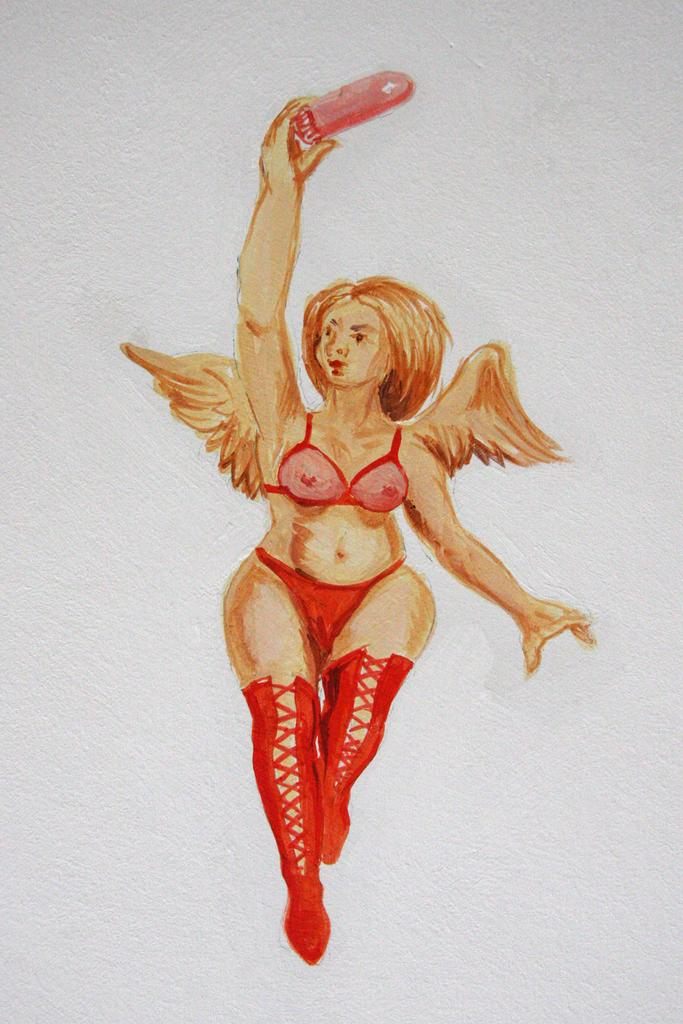What is the main subject of the painting in the image? The painting depicts a woman. Where is the painting located in the image? The painting is on a wall. What temperature is the painting stored at in the image? The image does not provide information about the temperature or storage conditions of the painting. What level of detail can be seen in the painting in the image? The image does not provide information about the level of detail in the painting. 